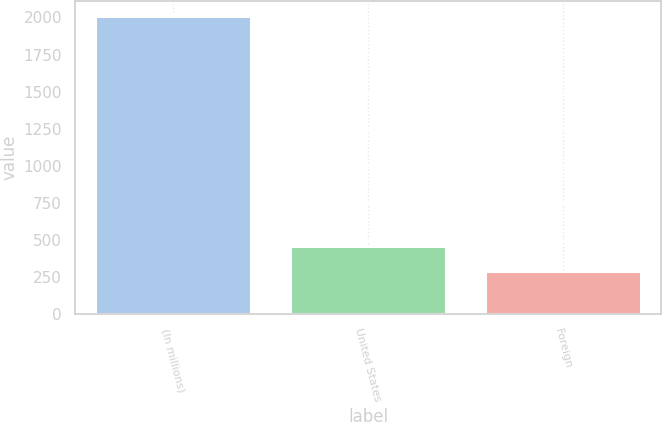Convert chart to OTSL. <chart><loc_0><loc_0><loc_500><loc_500><bar_chart><fcel>(In millions)<fcel>United States<fcel>Foreign<nl><fcel>2011<fcel>461.56<fcel>289.4<nl></chart> 